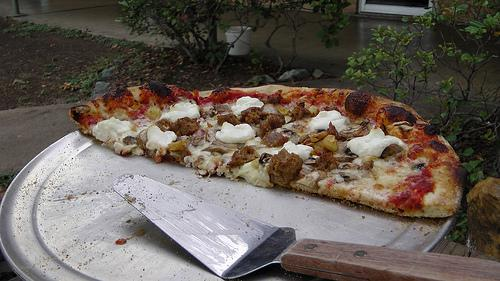Question: what color are the shrub leaves?
Choices:
A. Brown.
B. Red.
C. Green.
D. Yellow.
Answer with the letter. Answer: C Question: what kind of food is there?
Choices:
A. Burgers.
B. Hot dogs.
C. Nachos.
D. Pizza.
Answer with the letter. Answer: D Question: how much pizza is missing?
Choices:
A. One piece.
B. A quarter.
C. Half.
D. Two pieces.
Answer with the letter. Answer: C Question: what kind of meat is on the pizza?
Choices:
A. Pepperoni.
B. Sausage.
C. Ground beef.
D. Ham.
Answer with the letter. Answer: B Question: where was the picture taken?
Choices:
A. At a school.
B. At a library.
C. At home.
D. At a restaurant.
Answer with the letter. Answer: D 